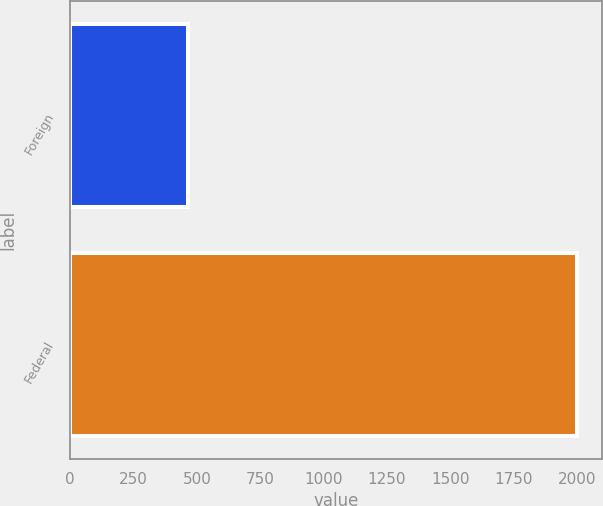Convert chart to OTSL. <chart><loc_0><loc_0><loc_500><loc_500><bar_chart><fcel>Foreign<fcel>Federal<nl><fcel>465<fcel>2000<nl></chart> 